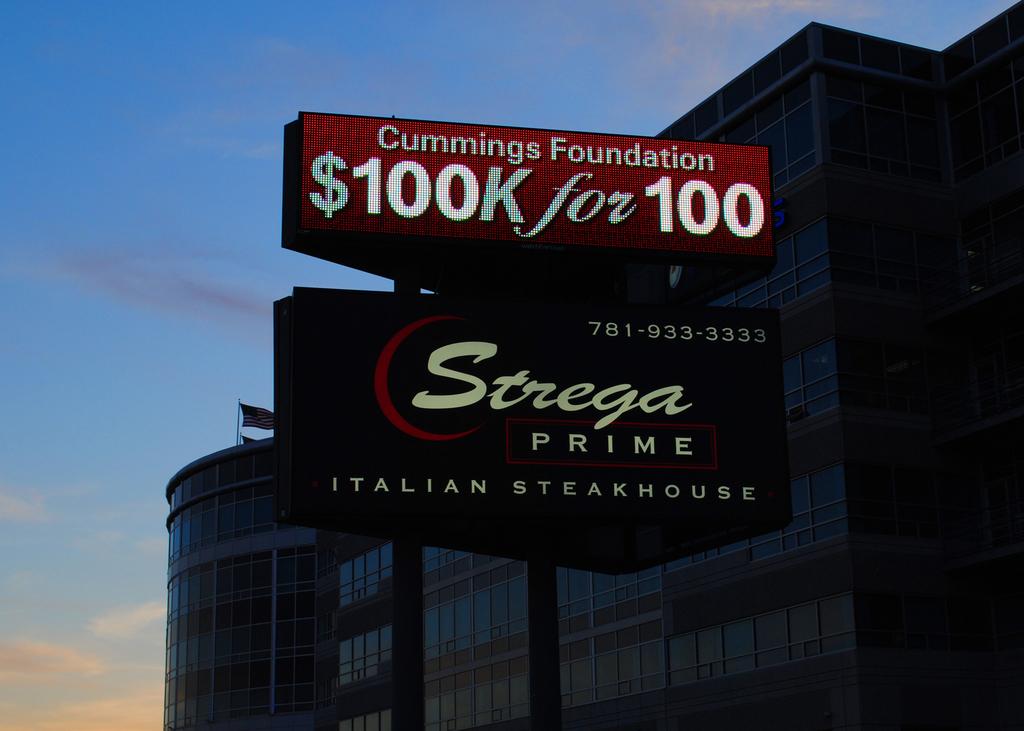What is strega's phone number?
Offer a very short reply. 781-933-3333. What is the name of the restaurant?
Your answer should be compact. Strega prime. 